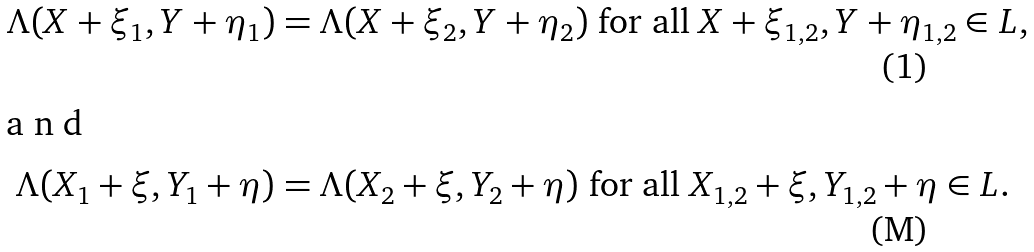Convert formula to latex. <formula><loc_0><loc_0><loc_500><loc_500>\Lambda ( X + \xi _ { 1 } , Y + \eta _ { 1 } ) & = \Lambda ( X + \xi _ { 2 } , Y + \eta _ { 2 } ) \text { for all } X + \xi _ { 1 , 2 } , Y + \eta _ { 1 , 2 } \in L , \intertext { a n d } \Lambda ( X _ { 1 } + \xi , Y _ { 1 } + \eta ) & = \Lambda ( X _ { 2 } + \xi , Y _ { 2 } + \eta ) \text { for all } X _ { 1 , 2 } + \xi , Y _ { 1 , 2 } + \eta \in L .</formula> 